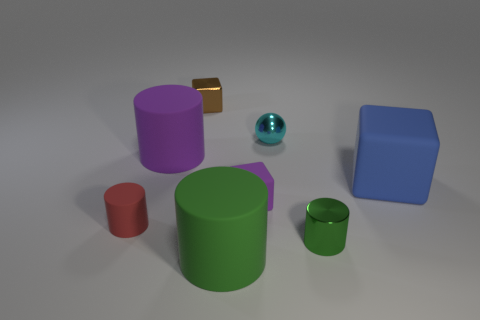Subtract 1 cylinders. How many cylinders are left? 3 Add 1 big rubber cubes. How many objects exist? 9 Subtract all cubes. How many objects are left? 5 Add 1 big green matte objects. How many big green matte objects are left? 2 Add 4 big green matte cylinders. How many big green matte cylinders exist? 5 Subtract 0 green cubes. How many objects are left? 8 Subtract all shiny blocks. Subtract all green metallic things. How many objects are left? 6 